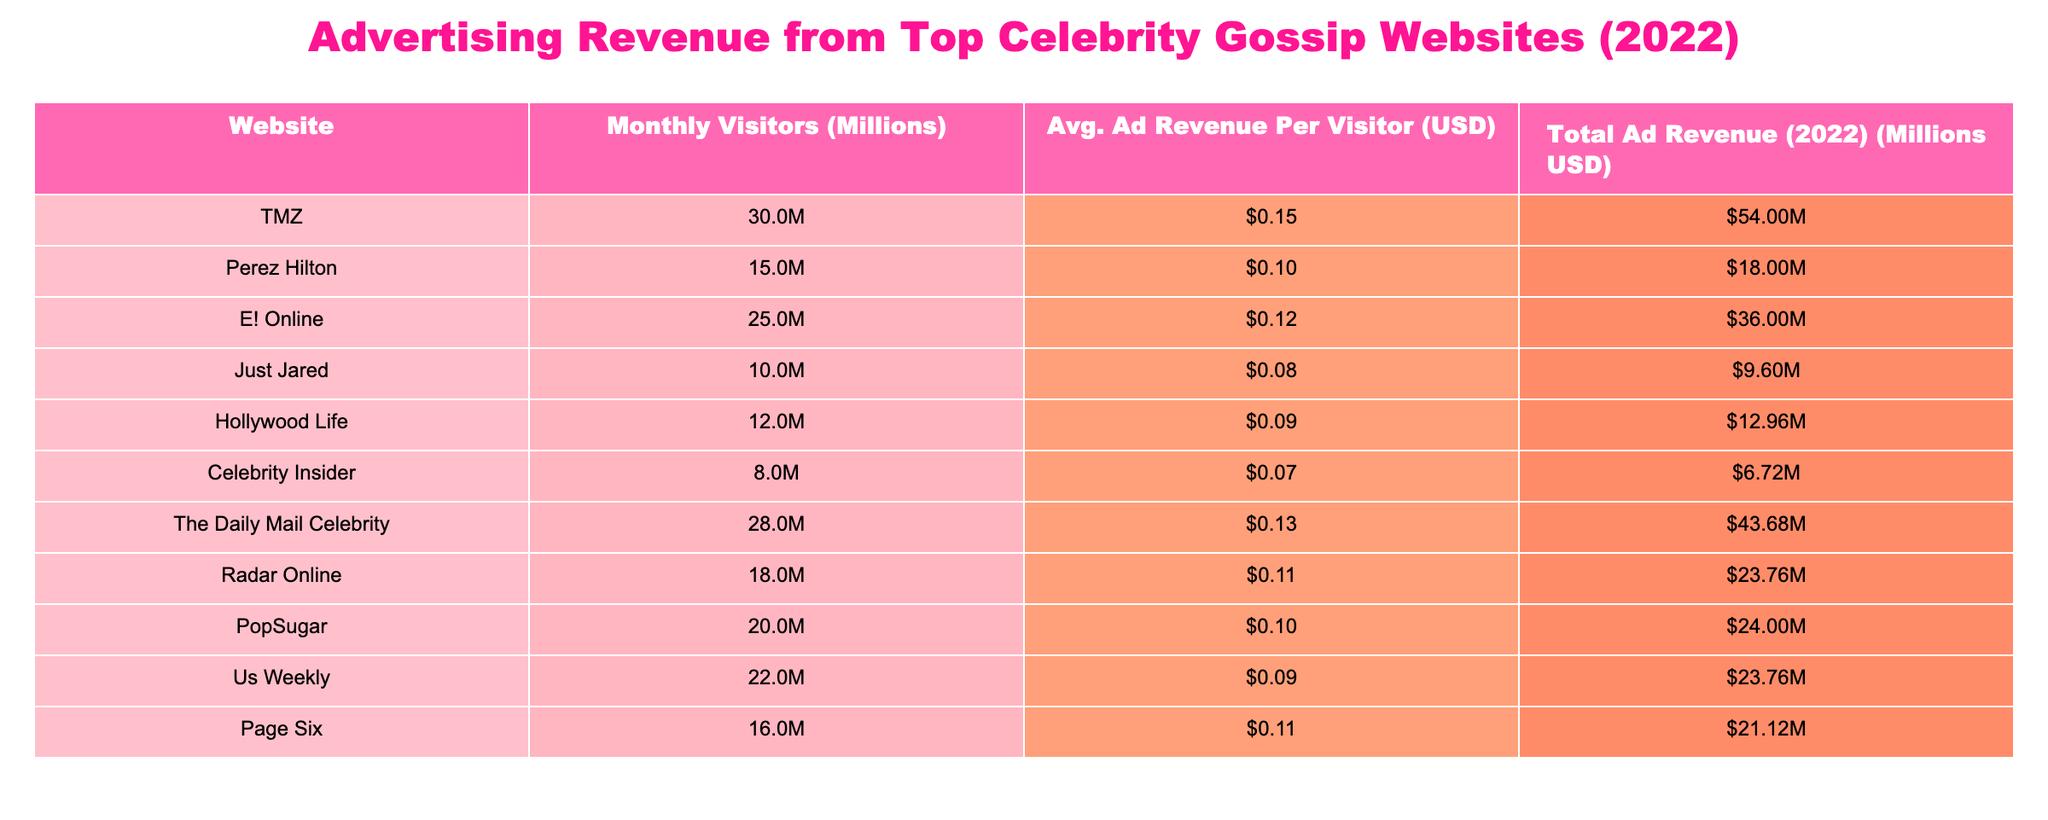What is the total advertising revenue for TMZ in 2022? According to the table, the total ad revenue for TMZ is listed under the "Total Ad Revenue (2022) (Millions USD)" column, which shows a value of 54.00 million USD.
Answer: 54.00 million USD Which website has the highest average ad revenue per visitor? To find the highest average ad revenue per visitor, we need to compare the values in the "Avg. Ad Revenue Per Visitor (USD)" column. The highest value is 0.15 USD for TMZ, indicating it has the highest average ad revenue per visitor.
Answer: TMZ What is the combined total advertising revenue of E! Online and Us Weekly in 2022? First, we find the total ad revenue for E! Online, which is 36.00 million USD. For Us Weekly, it is 23.76 million USD. Adding these together gives us 36.00 + 23.76 = 59.76 million USD.
Answer: 59.76 million USD Is there a website with less than 10 million in total ad revenue? Looking through the "Total Ad Revenue (2022) (Millions USD)" column, Celebrity Insider has 6.72 million USD, which is less than 10 million. Therefore, the statement is true.
Answer: Yes What is the average monthly visitors for all websites listed? To calculate the average, we first sum all the visitors: 30 + 15 + 25 + 10 + 12 + 8 + 28 + 18 + 20 + 22 + 16 =  24.0 million, and then divide by the number of websites, which is 11. This gives us an average of 24.0 / 11 = approximately 21.82 million.
Answer: 21.82 million Which celebrity gossip website had more than 20 million monthly visitors but with less than 0.12 USD average ad revenue per visitor? The websites with more than 20 million monthly visitors are TMZ, E! Online, The Daily Mail Celebrity, PopSugar, and Us Weekly. Among them, only Us Weekly had an average ad revenue of 0.09 USD, which is less than 0.12 USD.
Answer: Us Weekly What is the total advertising revenue from the websites that had average ad revenue per visitor greater than 0.10 USD? The websites with an average ad revenue greater than 0.10 USD are TMZ, The Daily Mail Celebrity, E! Online, and Radar Online. Their respective total ad revenues are 54.00, 43.68, 36.00, and 23.76 million USD. Adding these revenues together gives us 54.00 + 43.68 + 36.00 + 23.76 = 157.44 million USD.
Answer: 157.44 million USD How many websites reported total ad revenue above the average of all websites combined? First, we calculate the total revenue for all websites: 54.00 + 18.00 + 36.00 + 9.60 + 12.96 + 6.72 + 43.68 + 23.76 + 24.00 + 23.76 + 21.12 = 293.60 million USD. Dividing this by 11, the total number of websites, gives us an average advertising revenue of 26.69 million USD. Now, counting the websites with revenue above this average, we find 6 websites: TMZ, The Daily Mail Celebrity, E! Online, Radar Online, PopSugar, and Us Weekly.
Answer: 6 